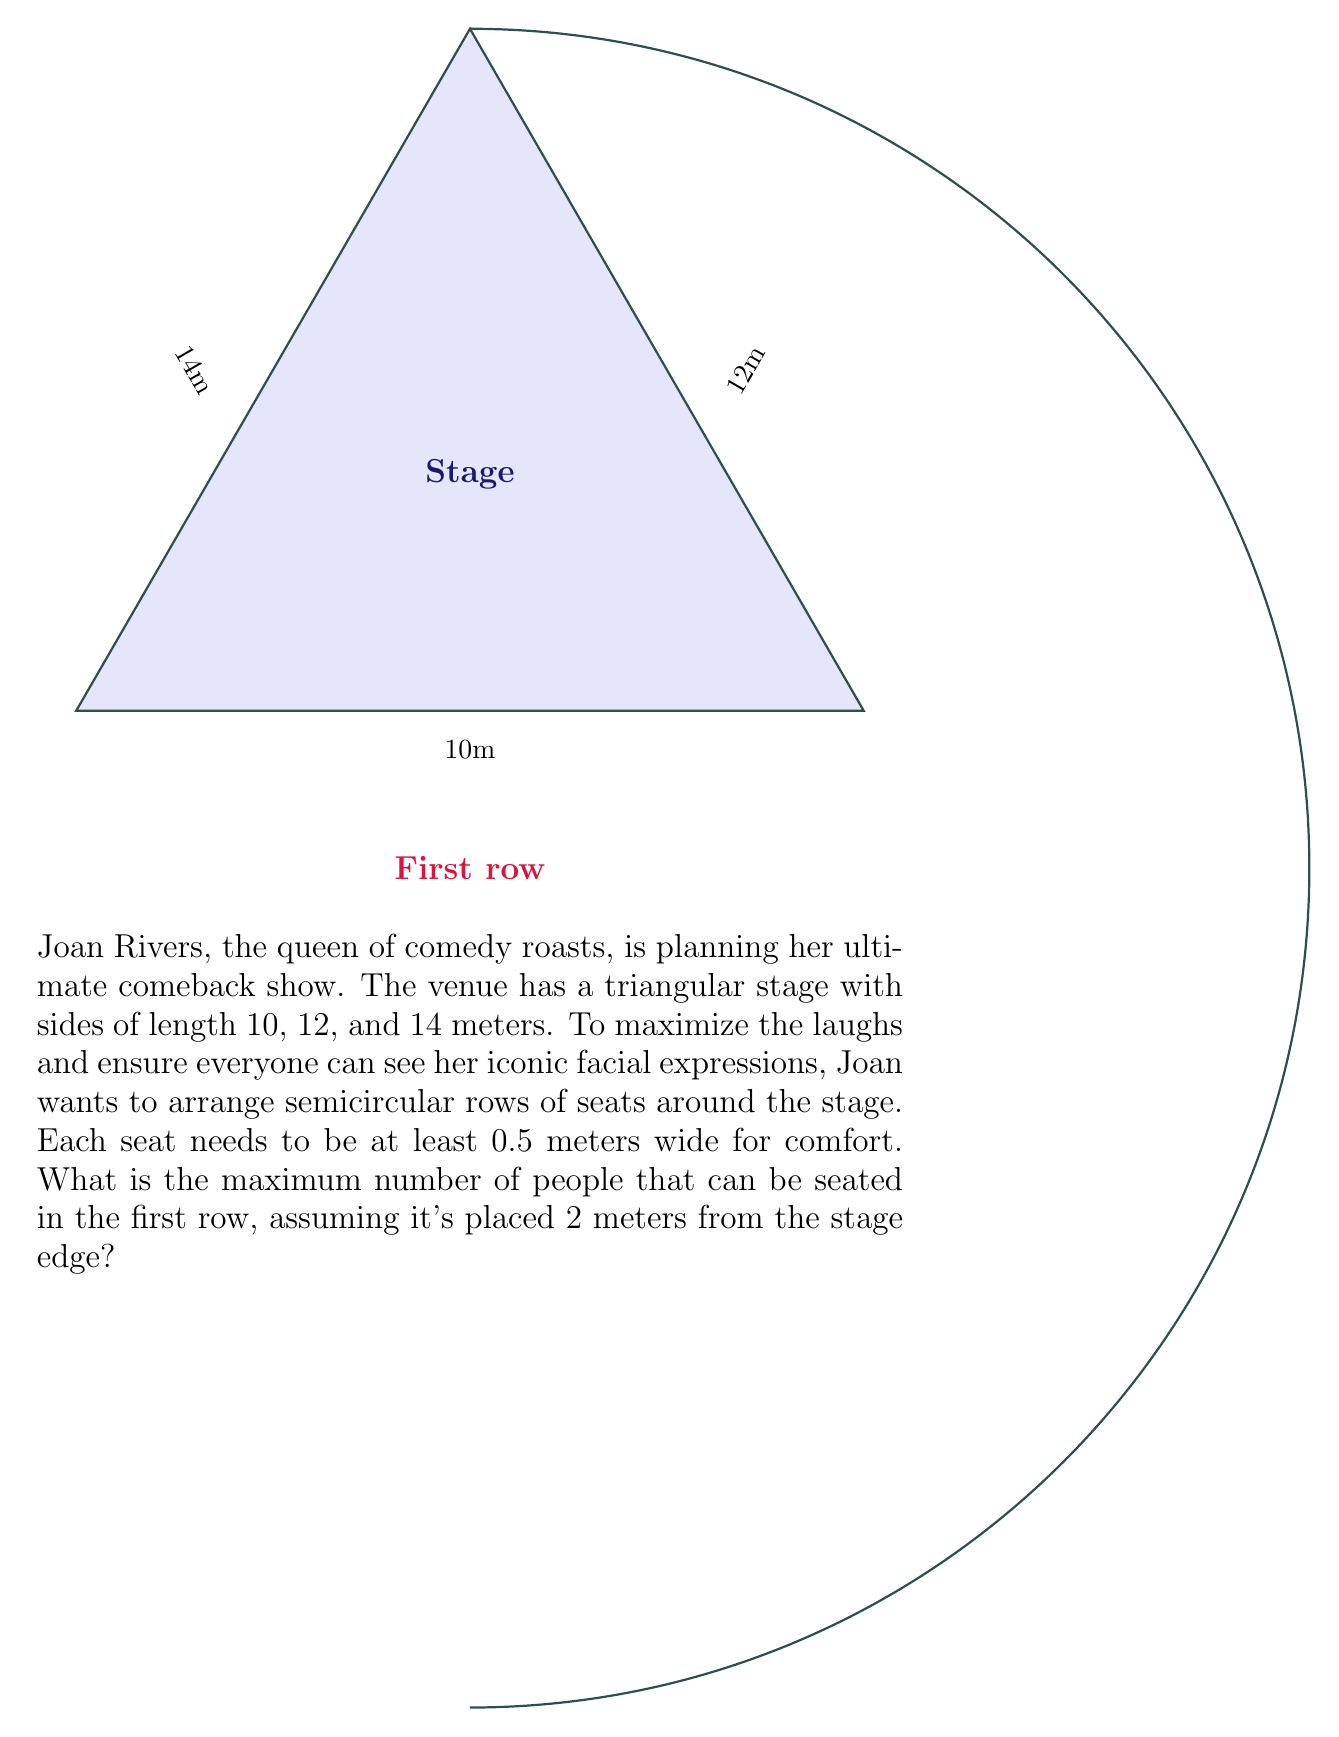Could you help me with this problem? Let's approach this step-by-step:

1) First, we need to calculate the semiperimeter of the stage:
   $s = \frac{10 + 12 + 14}{2} = 18$ meters

2) Now, we can use Heron's formula to calculate the area of the triangular stage:
   $A = \sqrt{s(s-a)(s-b)(s-c)}$
   $A = \sqrt{18(18-10)(18-12)(18-14)}$
   $A = \sqrt{18 \cdot 8 \cdot 6 \cdot 4} = \sqrt{3456} = 58.79$ sq meters

3) Given the area, we can calculate the radius of the inscribed circle:
   $r = \frac{A}{s} = \frac{58.79}{18} = 3.27$ meters

4) The first row is placed 2 meters from the stage edge, so its radius is:
   $R = r + 2 = 3.27 + 2 = 5.27$ meters

5) The circumference of this semicircle is:
   $C = \pi R = \pi \cdot 5.27 = 16.55$ meters

6) With each seat needing 0.5 meters, the maximum number of seats is:
   $N = \lfloor \frac{16.55}{0.5} \rfloor = \lfloor 33.1 \rfloor = 33$

Note: We use the floor function as we can't have a fractional number of seats.
Answer: 33 people 